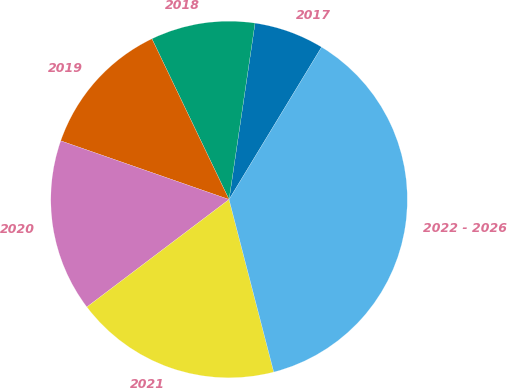<chart> <loc_0><loc_0><loc_500><loc_500><pie_chart><fcel>2017<fcel>2018<fcel>2019<fcel>2020<fcel>2021<fcel>2022 - 2026<nl><fcel>6.36%<fcel>9.45%<fcel>12.54%<fcel>15.64%<fcel>18.73%<fcel>37.28%<nl></chart> 